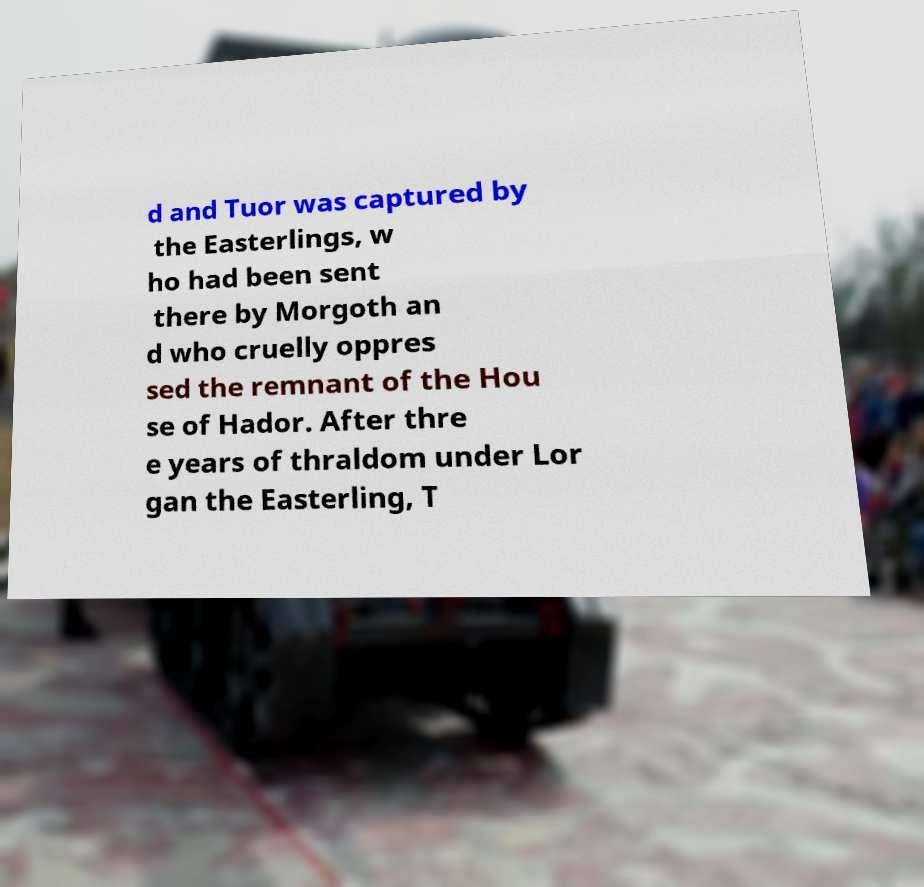Could you assist in decoding the text presented in this image and type it out clearly? d and Tuor was captured by the Easterlings, w ho had been sent there by Morgoth an d who cruelly oppres sed the remnant of the Hou se of Hador. After thre e years of thraldom under Lor gan the Easterling, T 